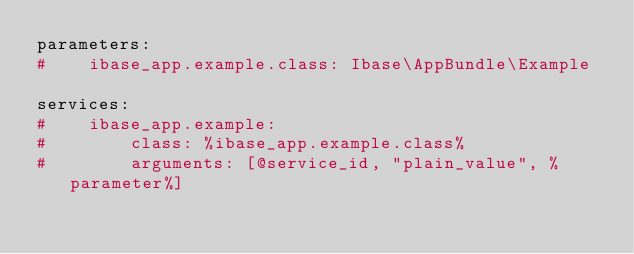<code> <loc_0><loc_0><loc_500><loc_500><_YAML_>parameters:
#    ibase_app.example.class: Ibase\AppBundle\Example

services:
#    ibase_app.example:
#        class: %ibase_app.example.class%
#        arguments: [@service_id, "plain_value", %parameter%]
</code> 